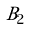<formula> <loc_0><loc_0><loc_500><loc_500>\tilde { B } _ { 2 }</formula> 